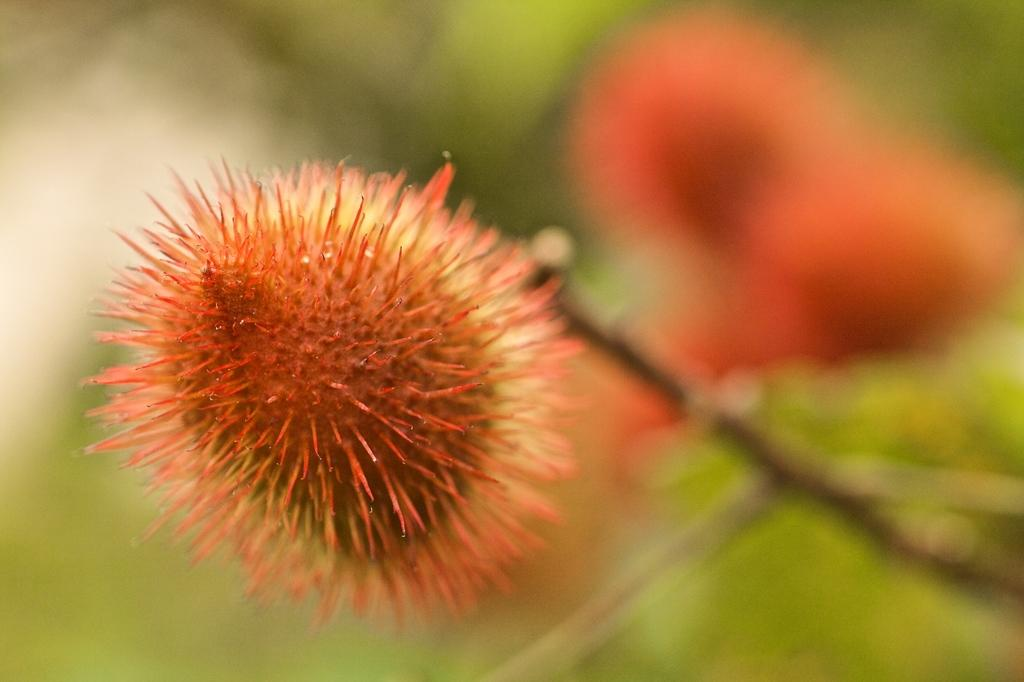What type of objects can be seen in the image? There are flowers in the image. What color are the flowers? The flowers are red in color. Can you describe the background of the image? The background of the image is blurred. How many kites are flying in the image? There are no kites present in the image; it features red flowers with a blurred background. What is located at the top of the flowers in the image? The flowers do not have anything specific located at the top in the image. 